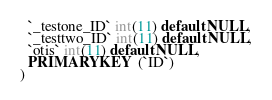Convert code to text. <code><loc_0><loc_0><loc_500><loc_500><_SQL_>  `_testone_ID` int(11) default NULL,
  `_testtwo_ID` int(11) default NULL,
  `otis` int(11) default NULL,
  PRIMARY KEY  (`ID`)
) </code> 